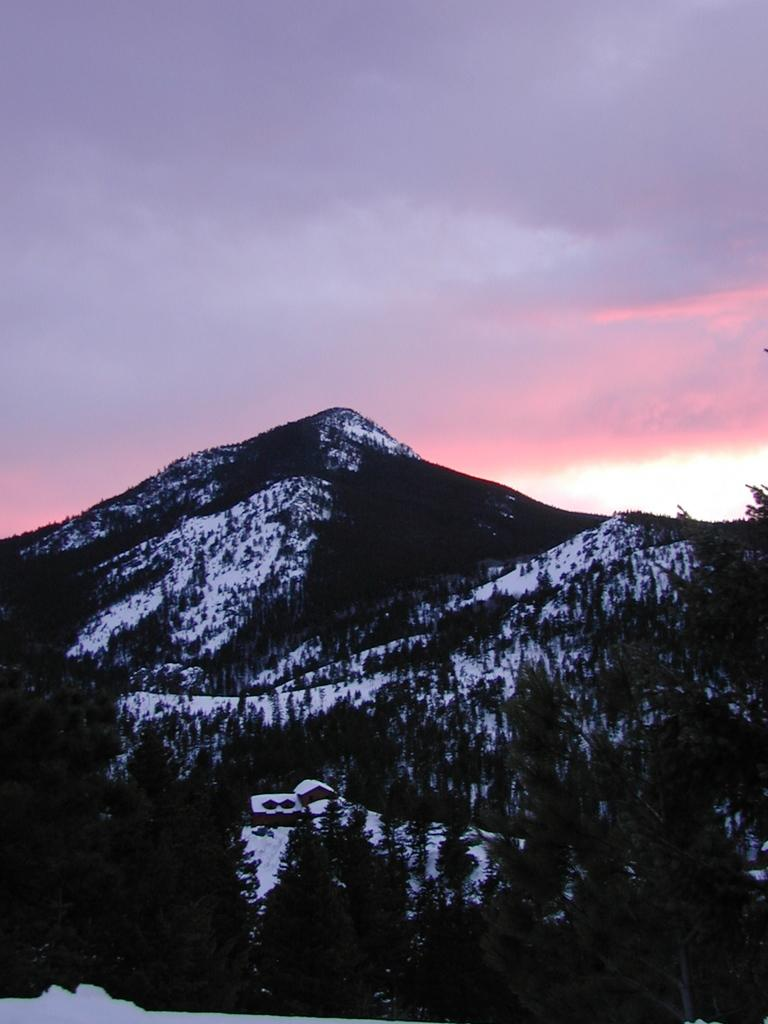What type of natural landscape is depicted in the image? The image features mountains and trees. What type of structure can be seen in the image? There is a house in the image. What is the weather like in the image? There is snow visible in the image, indicating a cold climate. What is visible in the sky in the image? The sky is visible in the image, and clouds are present. What type of summer activity is taking place in the image? There is no summer activity present in the image, as the presence of snow indicates a cold climate. Can you see a leg sticking out from behind the house in the image? There is no leg visible in the image; the focus is on the natural landscape and the house. 